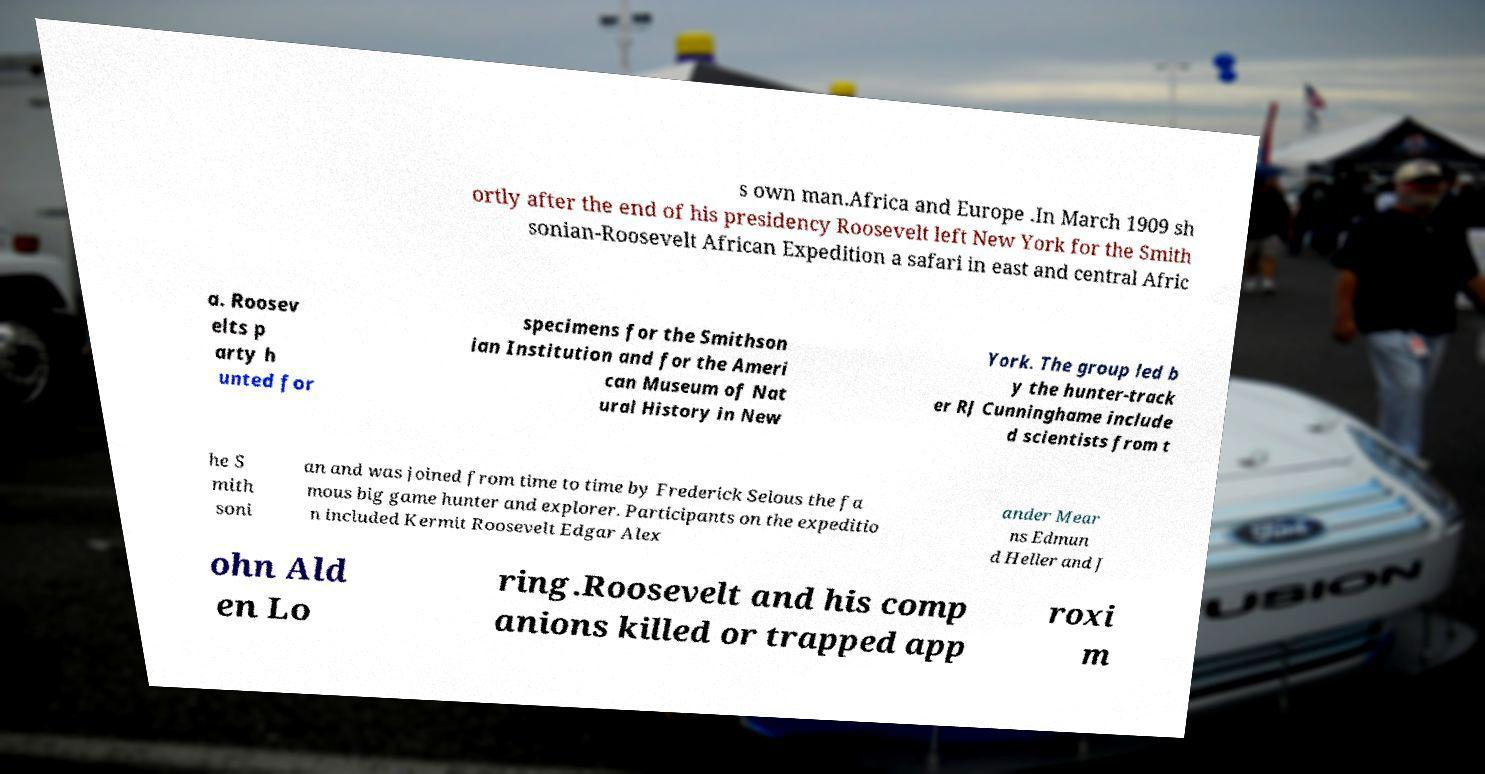There's text embedded in this image that I need extracted. Can you transcribe it verbatim? s own man.Africa and Europe .In March 1909 sh ortly after the end of his presidency Roosevelt left New York for the Smith sonian-Roosevelt African Expedition a safari in east and central Afric a. Roosev elts p arty h unted for specimens for the Smithson ian Institution and for the Ameri can Museum of Nat ural History in New York. The group led b y the hunter-track er RJ Cunninghame include d scientists from t he S mith soni an and was joined from time to time by Frederick Selous the fa mous big game hunter and explorer. Participants on the expeditio n included Kermit Roosevelt Edgar Alex ander Mear ns Edmun d Heller and J ohn Ald en Lo ring.Roosevelt and his comp anions killed or trapped app roxi m 